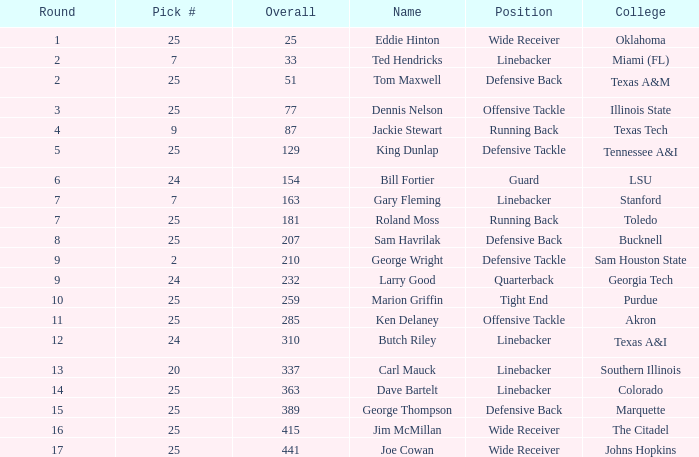Circle greater than 6, and a selection # less than 25, and a university of southern illinois holds which rank? Linebacker. 